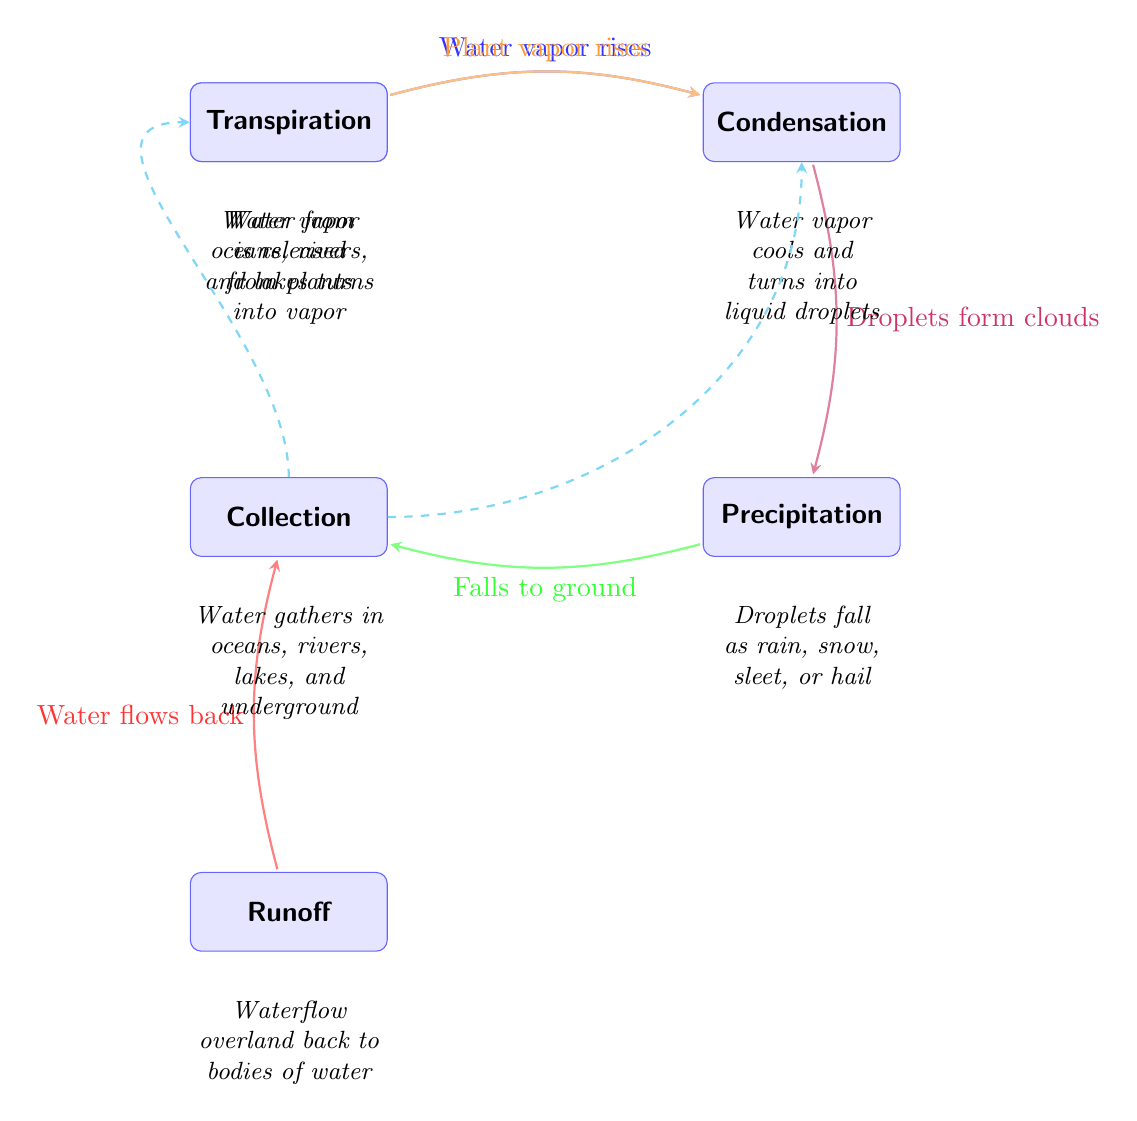What is the first process in the diagram? The diagram shows evaporation as the first process, which is the starting point of the water cycle. It is positioned at the top left of the diagram.
Answer: Evaporation How many processes are depicted in the diagram? There are six processes shown in the diagram: Evaporation, Condensation, Precipitation, Collection, Transpiration, and Runoff.
Answer: Six What forms after condensation according to the diagram? According to the diagram, condensation leads to the formation of droplets that create clouds, which are represented in the transition from the Condensation node to the Precipitation node.
Answer: Droplets Which two processes are linked directly by a water flow return? The link goes from Runoff to Collection, indicating that water flows back into bodies of water after runoff. This is represented by the red arrow connecting these two processes.
Answer: Runoff and Collection What type of weather events fall under the precipitation phase? Precipitation includes various forms like rain, snow, sleet, or hail, which are detailed in the description that follows the Precipitation node.
Answer: Rain, snow, sleet, or hail How does transpiration contribute to condensation? Transpiration adds water vapor that rises and contributes to condensation, illustrated by the orange arrow that connects Transpiration to Condensation in the diagram.
Answer: Water vapor Explain the flow of water in the cycle from collection to evaporation. The flow of water starts from Collection, where it gathers in various bodies like oceans and lakes, and then it rises as vapor (evaporation) back to the atmosphere. This cyclical path is illustrated by the dashed cyan arrow looping from Collection back to Evaporation.
Answer: Collection to Evaporation What process is located directly below Precipitation? Runoff is located directly below Precipitation in the diagram, showing its position in relation to the other nodes in the water cycle.
Answer: Runoff What happens to water vapor when it condenses? When water vapor condenses, it cools down and turns into liquid droplets, as stated in the detailed description below the Condensation node in the diagram.
Answer: Turns into liquid droplets 